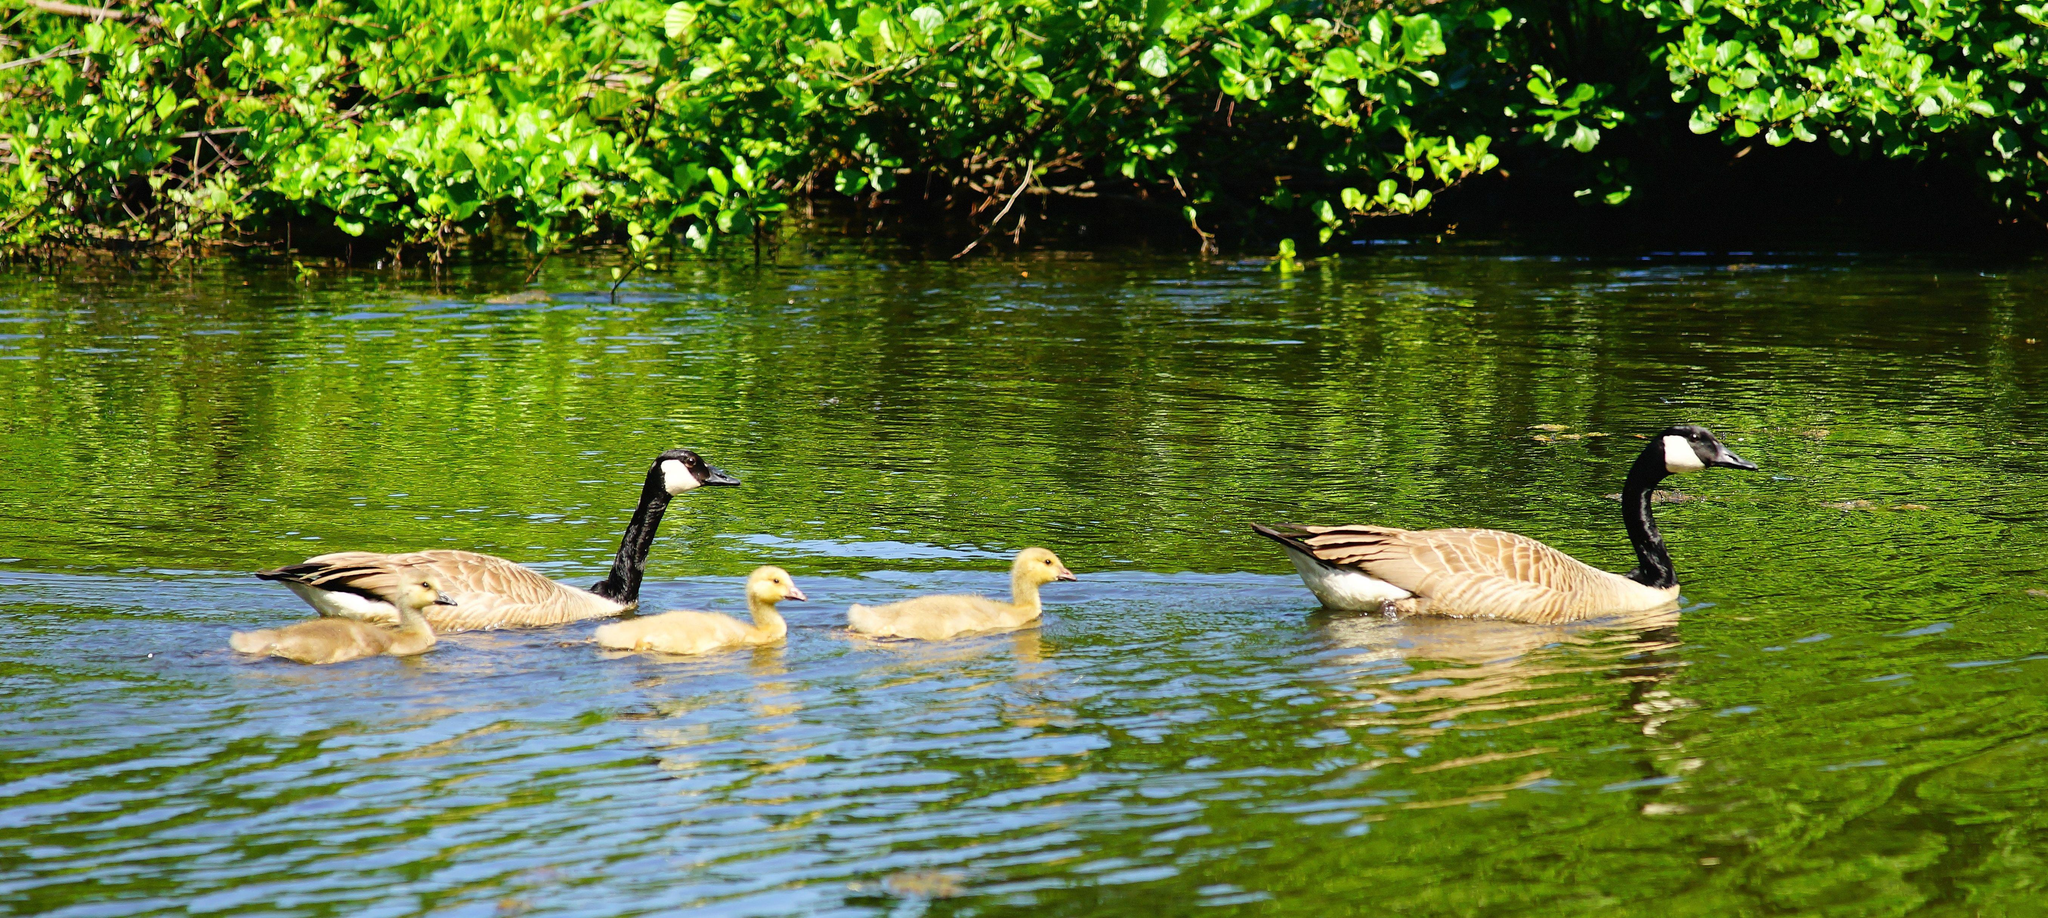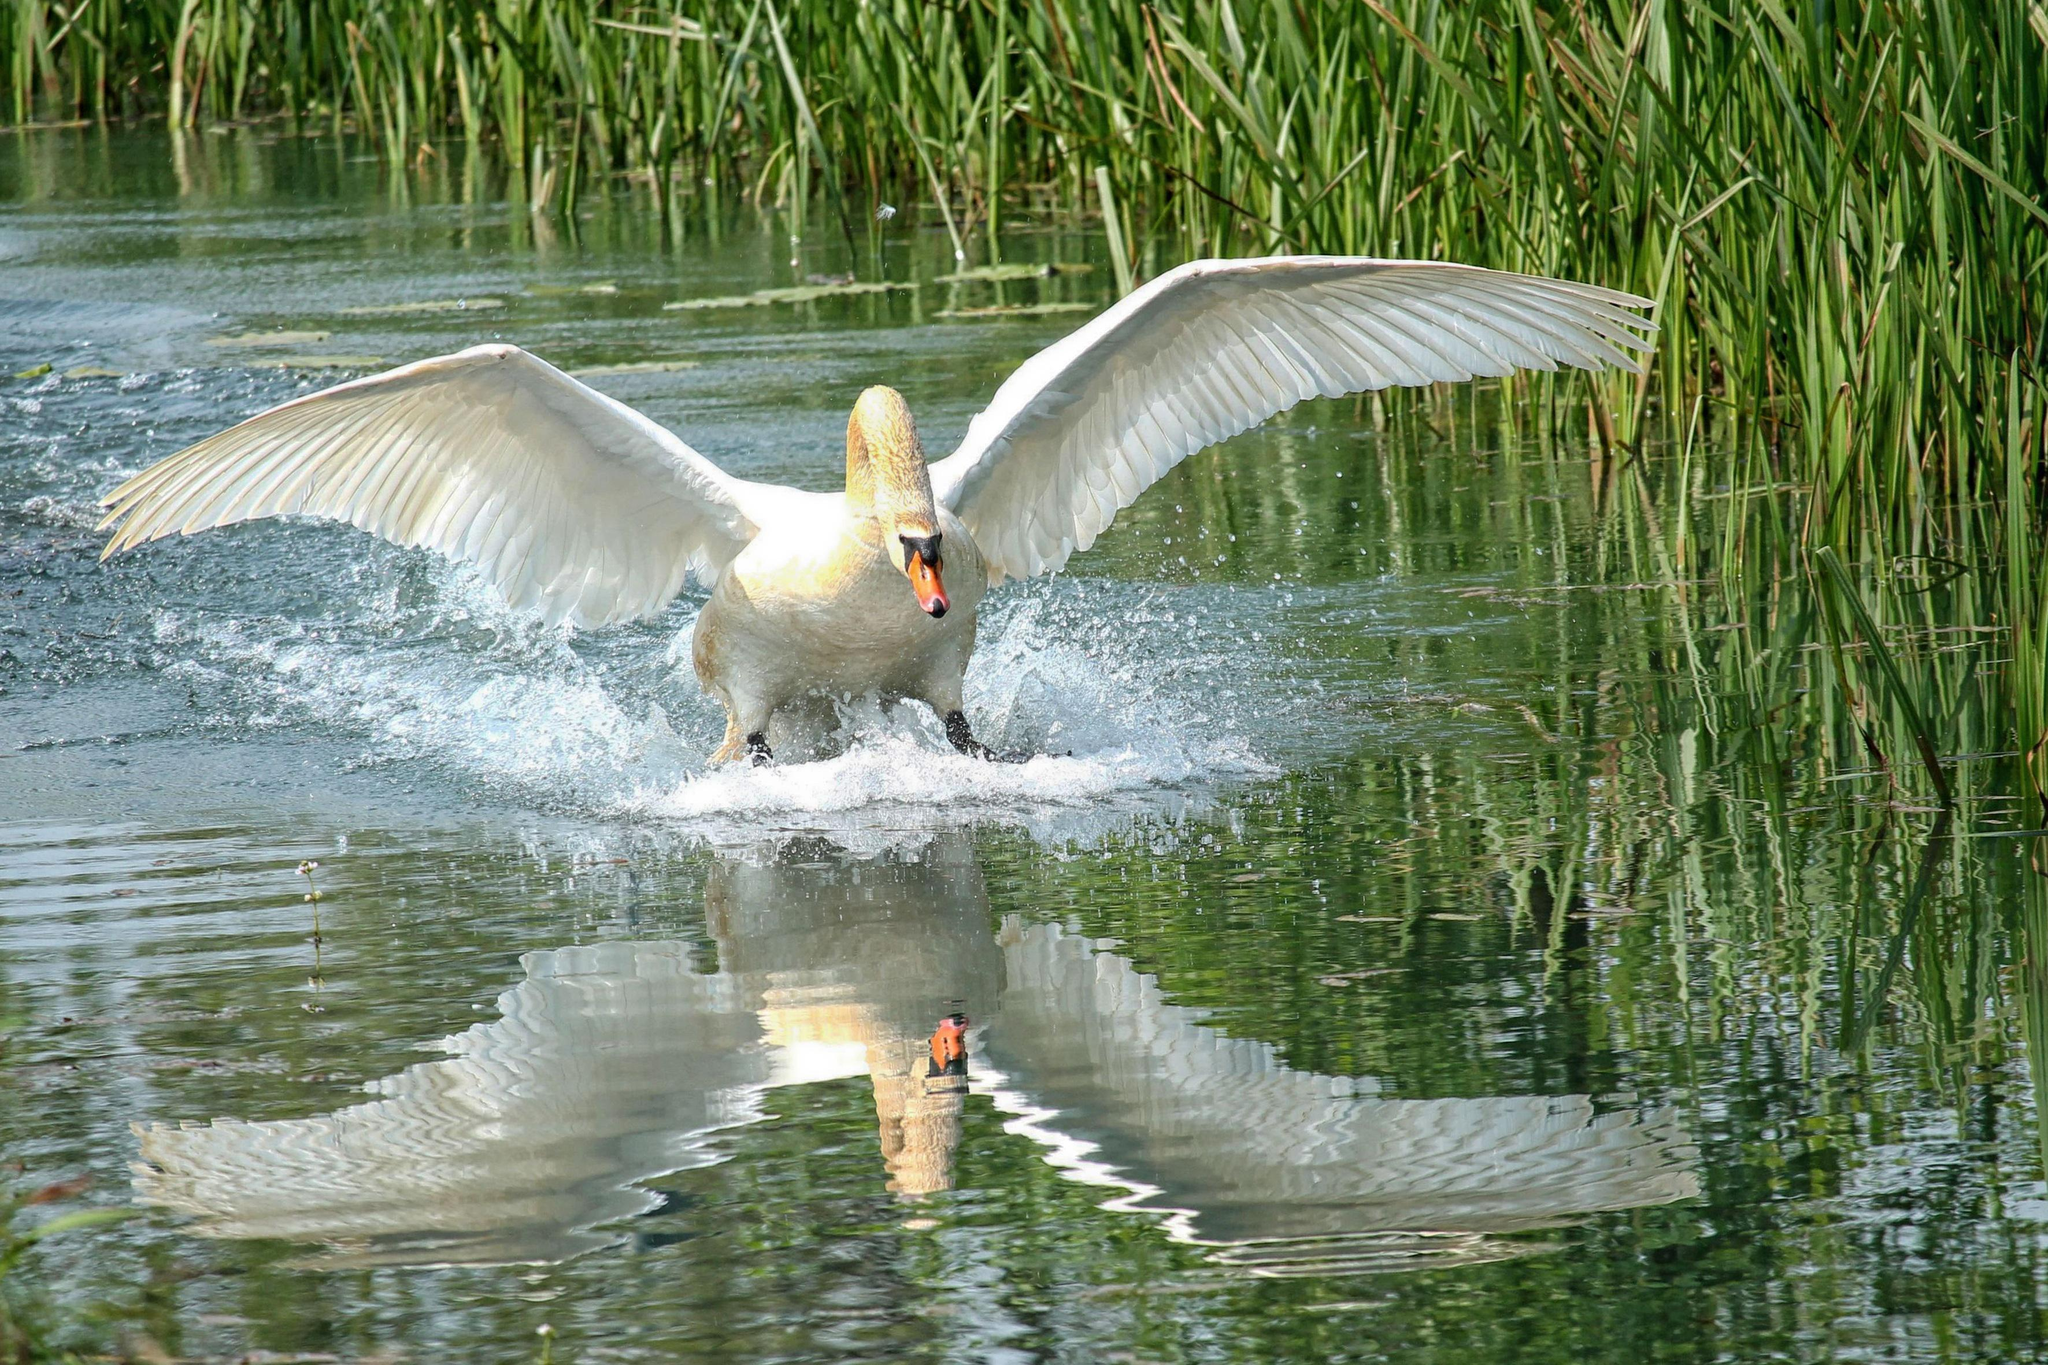The first image is the image on the left, the second image is the image on the right. Analyze the images presented: Is the assertion "One image contains at least one swan, and the other image contains at least one goose." valid? Answer yes or no. Yes. The first image is the image on the left, the second image is the image on the right. Analyze the images presented: Is the assertion "Every single image features more than one bird." valid? Answer yes or no. No. 